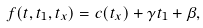<formula> <loc_0><loc_0><loc_500><loc_500>f ( t , t _ { 1 } , t _ { x } ) = c ( t _ { x } ) + \gamma t _ { 1 } + \beta ,</formula> 